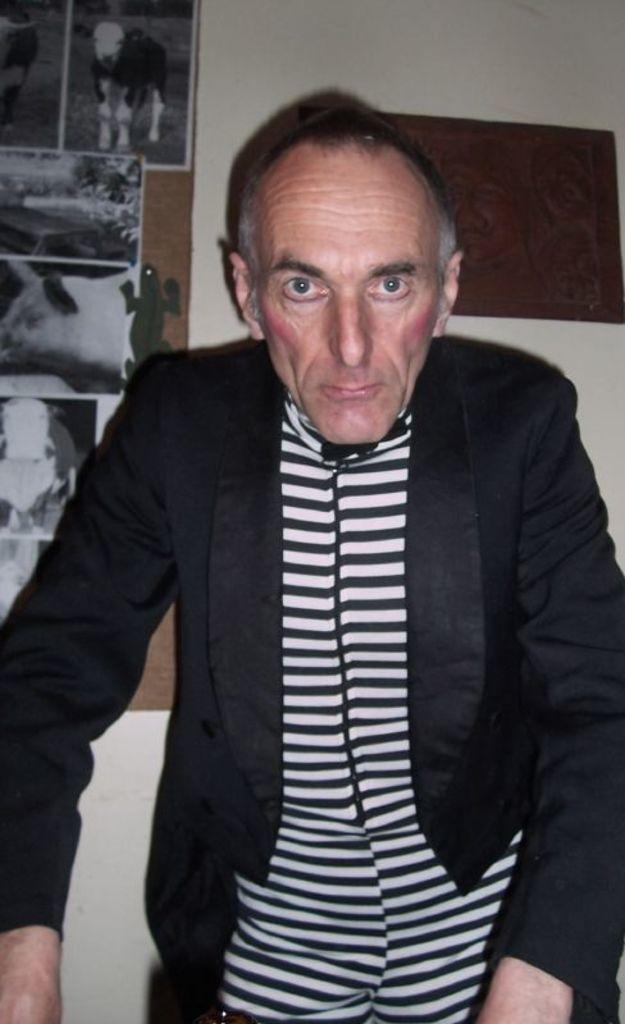Who or what is present in the image? There is a person in the image. What is the person wearing? The person is wearing a black coat. Where is the person standing? The person is standing on the floor. What can be seen in the background of the image? There is a group of photos on the wall in the background. What type of instrument is the person playing in the image? There is no instrument present in the image, and the person is not playing any instrument. 